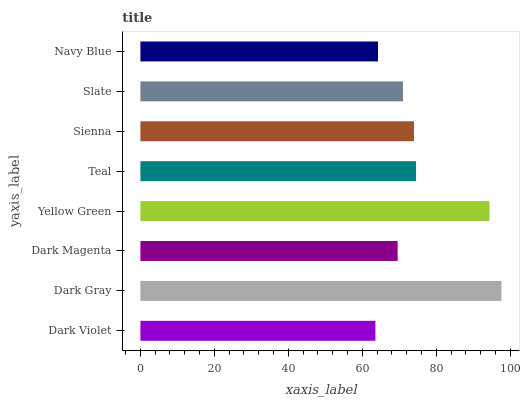Is Dark Violet the minimum?
Answer yes or no. Yes. Is Dark Gray the maximum?
Answer yes or no. Yes. Is Dark Magenta the minimum?
Answer yes or no. No. Is Dark Magenta the maximum?
Answer yes or no. No. Is Dark Gray greater than Dark Magenta?
Answer yes or no. Yes. Is Dark Magenta less than Dark Gray?
Answer yes or no. Yes. Is Dark Magenta greater than Dark Gray?
Answer yes or no. No. Is Dark Gray less than Dark Magenta?
Answer yes or no. No. Is Sienna the high median?
Answer yes or no. Yes. Is Slate the low median?
Answer yes or no. Yes. Is Dark Magenta the high median?
Answer yes or no. No. Is Yellow Green the low median?
Answer yes or no. No. 